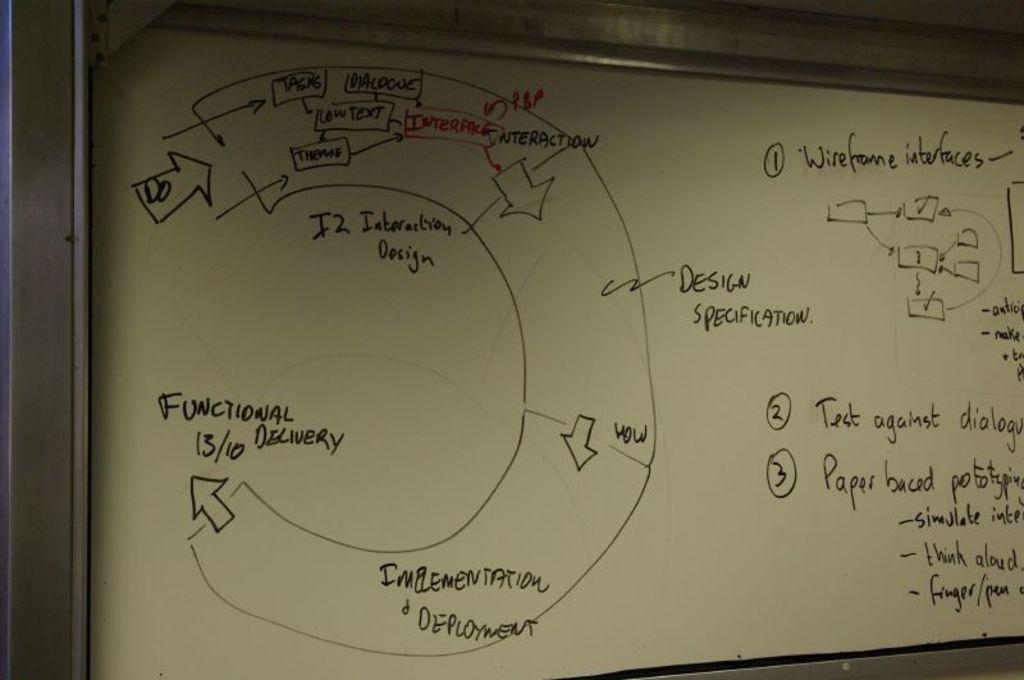What kind of interfaces are mentioned?
Make the answer very short. Wireframe. 